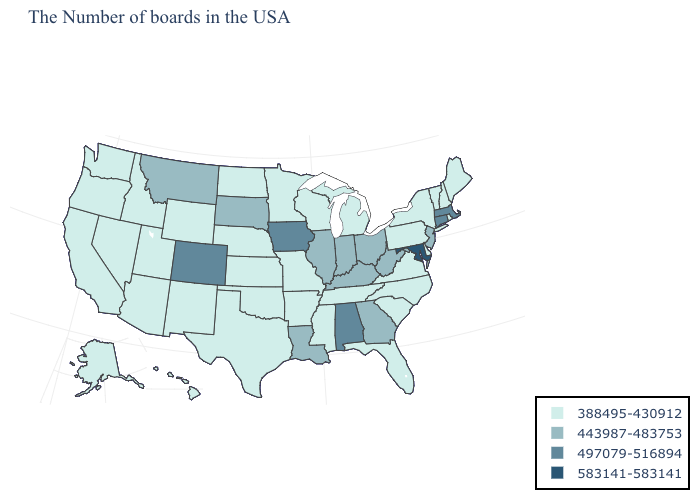Among the states that border Oklahoma , does Arkansas have the lowest value?
Concise answer only. Yes. Name the states that have a value in the range 497079-516894?
Quick response, please. Massachusetts, Connecticut, Alabama, Iowa, Colorado. What is the value of Michigan?
Give a very brief answer. 388495-430912. Among the states that border Kentucky , does Tennessee have the lowest value?
Write a very short answer. Yes. What is the highest value in the MidWest ?
Answer briefly. 497079-516894. What is the lowest value in the USA?
Quick response, please. 388495-430912. Does Minnesota have the lowest value in the USA?
Concise answer only. Yes. Does Maryland have the highest value in the USA?
Short answer required. Yes. Which states hav the highest value in the MidWest?
Be succinct. Iowa. Does Tennessee have the lowest value in the USA?
Concise answer only. Yes. Name the states that have a value in the range 583141-583141?
Give a very brief answer. Maryland. Name the states that have a value in the range 497079-516894?
Quick response, please. Massachusetts, Connecticut, Alabama, Iowa, Colorado. Name the states that have a value in the range 583141-583141?
Write a very short answer. Maryland. What is the value of New Jersey?
Write a very short answer. 443987-483753. Name the states that have a value in the range 388495-430912?
Give a very brief answer. Maine, Rhode Island, New Hampshire, Vermont, New York, Delaware, Pennsylvania, Virginia, North Carolina, South Carolina, Florida, Michigan, Tennessee, Wisconsin, Mississippi, Missouri, Arkansas, Minnesota, Kansas, Nebraska, Oklahoma, Texas, North Dakota, Wyoming, New Mexico, Utah, Arizona, Idaho, Nevada, California, Washington, Oregon, Alaska, Hawaii. 